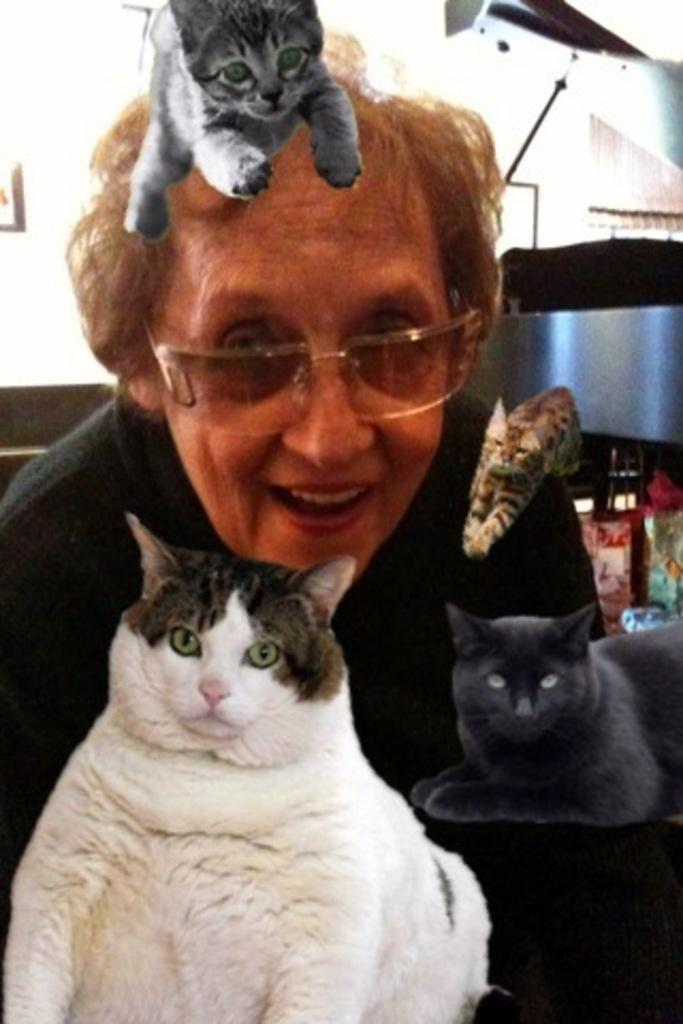Who or what is present in the image? There is a person in the image. What is the person doing or expressing? The person is smiling. Are there any animals in the image? Yes, there are cats in the image. What can be seen in the background of the image? There is a wall and some objects in the background of the image. How many tails can be seen on the person in the image? There are no tails visible on the person in the image, as humans do not have tails. 